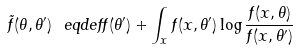Convert formula to latex. <formula><loc_0><loc_0><loc_500><loc_500>\tilde { f } ( \theta , \theta ^ { \prime } ) \ e q d e f f ( \theta ^ { \prime } ) + \int _ { x } f ( x , \theta ^ { \prime } ) \log \frac { f ( x , \theta ) } { f ( x , \theta ^ { \prime } ) }</formula> 